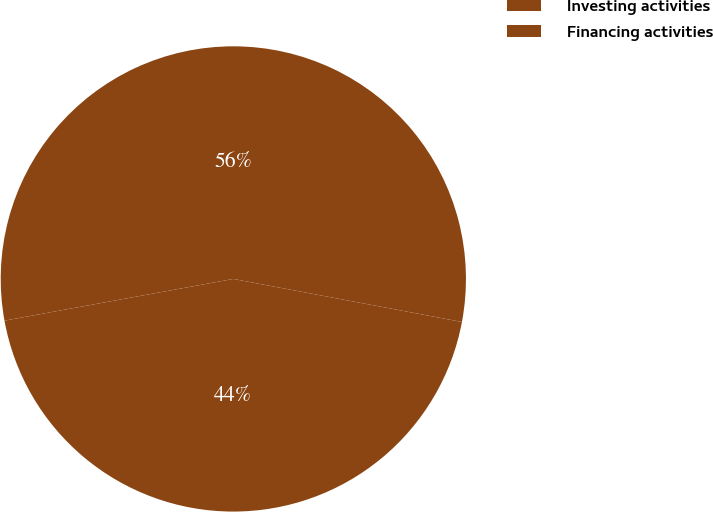Convert chart. <chart><loc_0><loc_0><loc_500><loc_500><pie_chart><fcel>Investing activities<fcel>Financing activities<nl><fcel>55.83%<fcel>44.17%<nl></chart> 